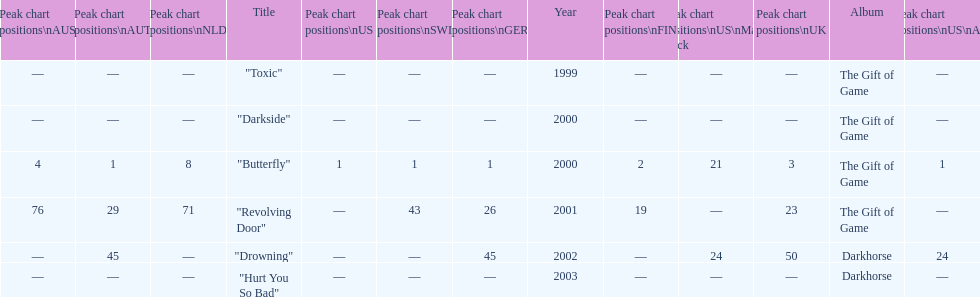How many singles have a ranking of 1 under ger? 1. 